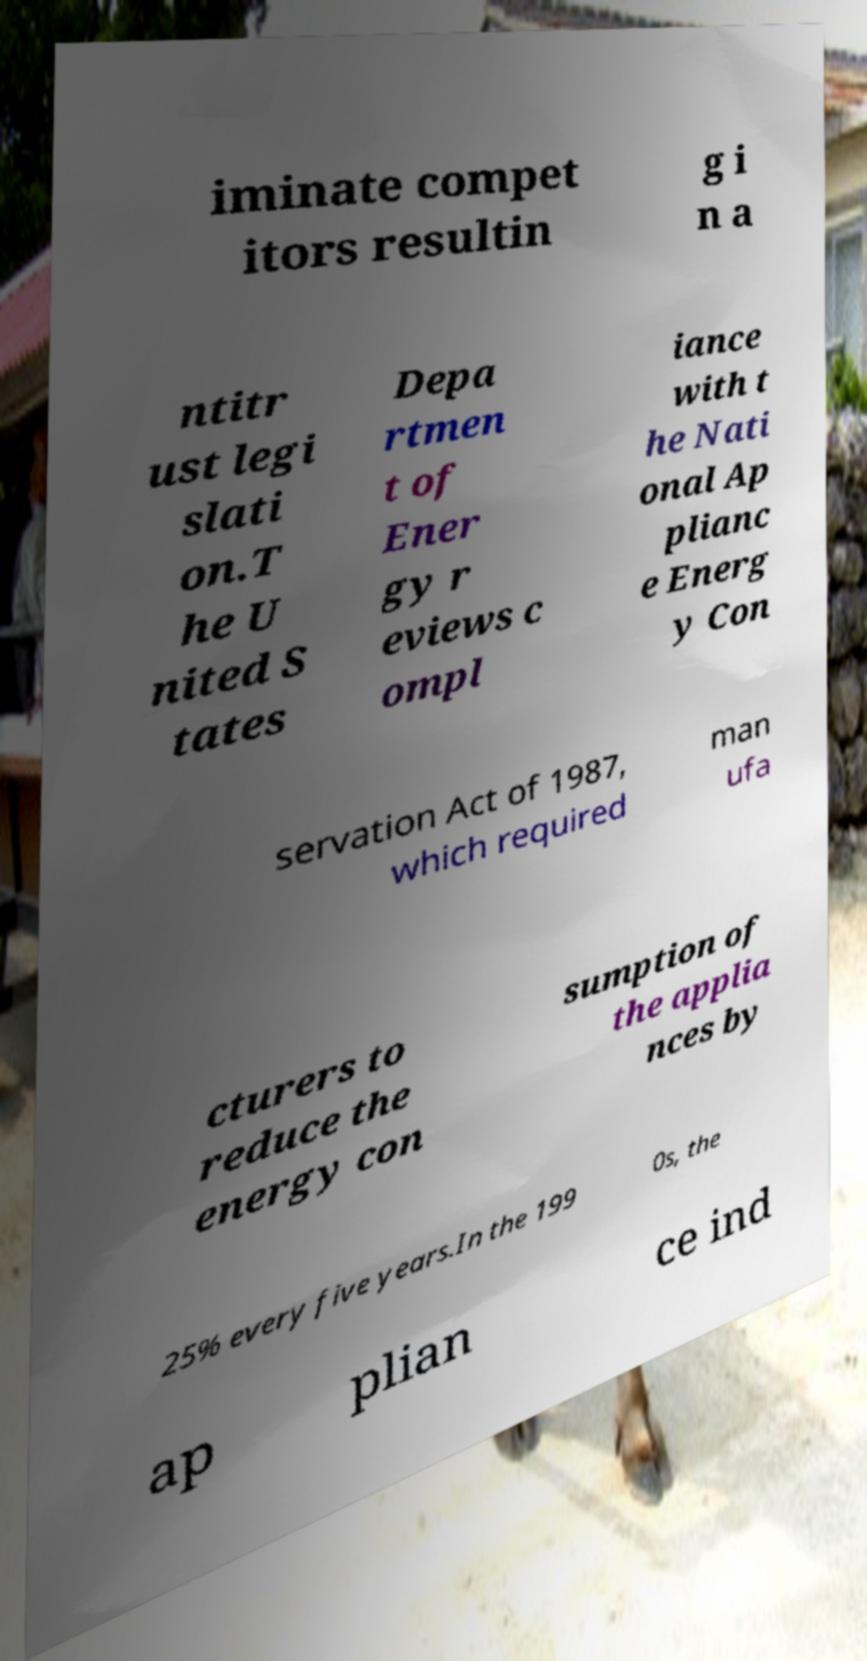I need the written content from this picture converted into text. Can you do that? iminate compet itors resultin g i n a ntitr ust legi slati on.T he U nited S tates Depa rtmen t of Ener gy r eviews c ompl iance with t he Nati onal Ap plianc e Energ y Con servation Act of 1987, which required man ufa cturers to reduce the energy con sumption of the applia nces by 25% every five years.In the 199 0s, the ap plian ce ind 